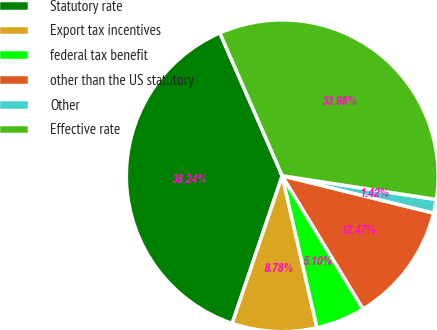Convert chart. <chart><loc_0><loc_0><loc_500><loc_500><pie_chart><fcel>Statutory rate<fcel>Export tax incentives<fcel>federal tax benefit<fcel>other than the US statutory<fcel>Other<fcel>Effective rate<nl><fcel>38.24%<fcel>8.78%<fcel>5.1%<fcel>12.47%<fcel>1.42%<fcel>33.98%<nl></chart> 